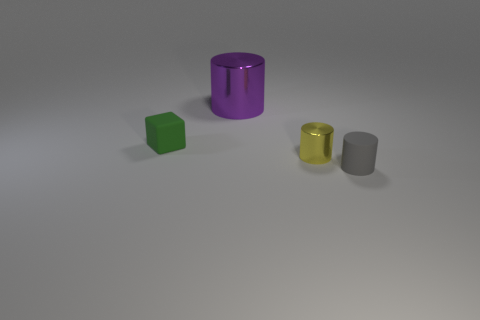Add 2 tiny rubber cylinders. How many objects exist? 6 Subtract all cylinders. How many objects are left? 1 Subtract 0 cyan balls. How many objects are left? 4 Subtract all green rubber objects. Subtract all large purple cylinders. How many objects are left? 2 Add 2 yellow cylinders. How many yellow cylinders are left? 3 Add 4 yellow metal things. How many yellow metal things exist? 5 